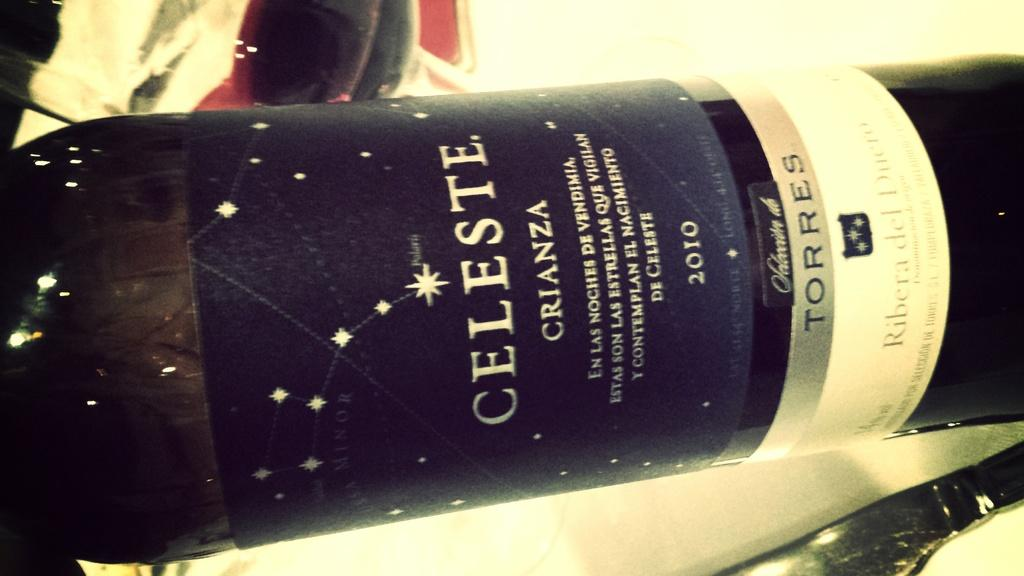<image>
Provide a brief description of the given image. A bottle of Celeste CRIANZA 2010 wine is pictured. 